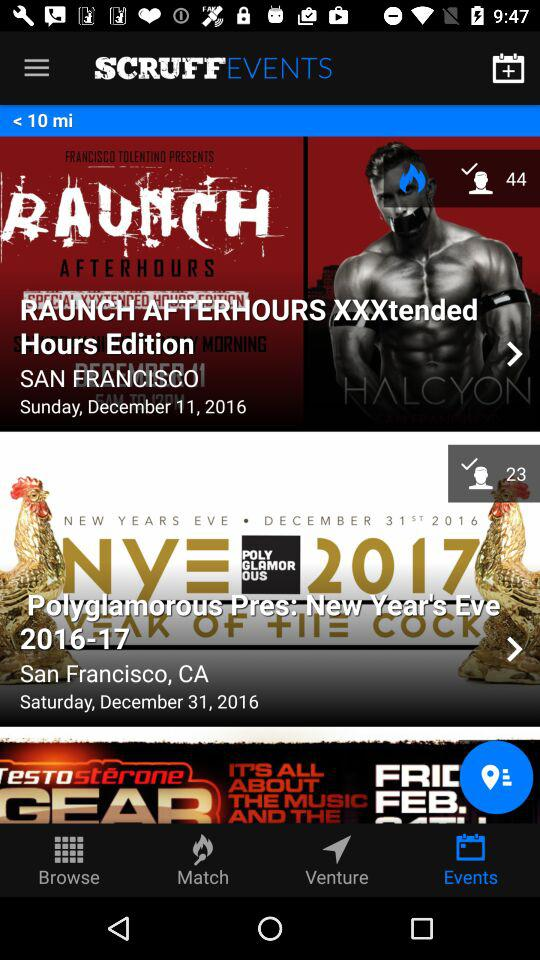What is the date of "Polyglamorous Pres: New Year's Eve 2016-17"? The date is Saturday, December 31, 2016. 